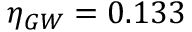Convert formula to latex. <formula><loc_0><loc_0><loc_500><loc_500>\eta _ { G W } = 0 . 1 3 3</formula> 